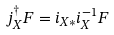<formula> <loc_0><loc_0><loc_500><loc_500>j _ { X } ^ { \dagger } F = i _ { X * } i _ { X } ^ { - 1 } F</formula> 